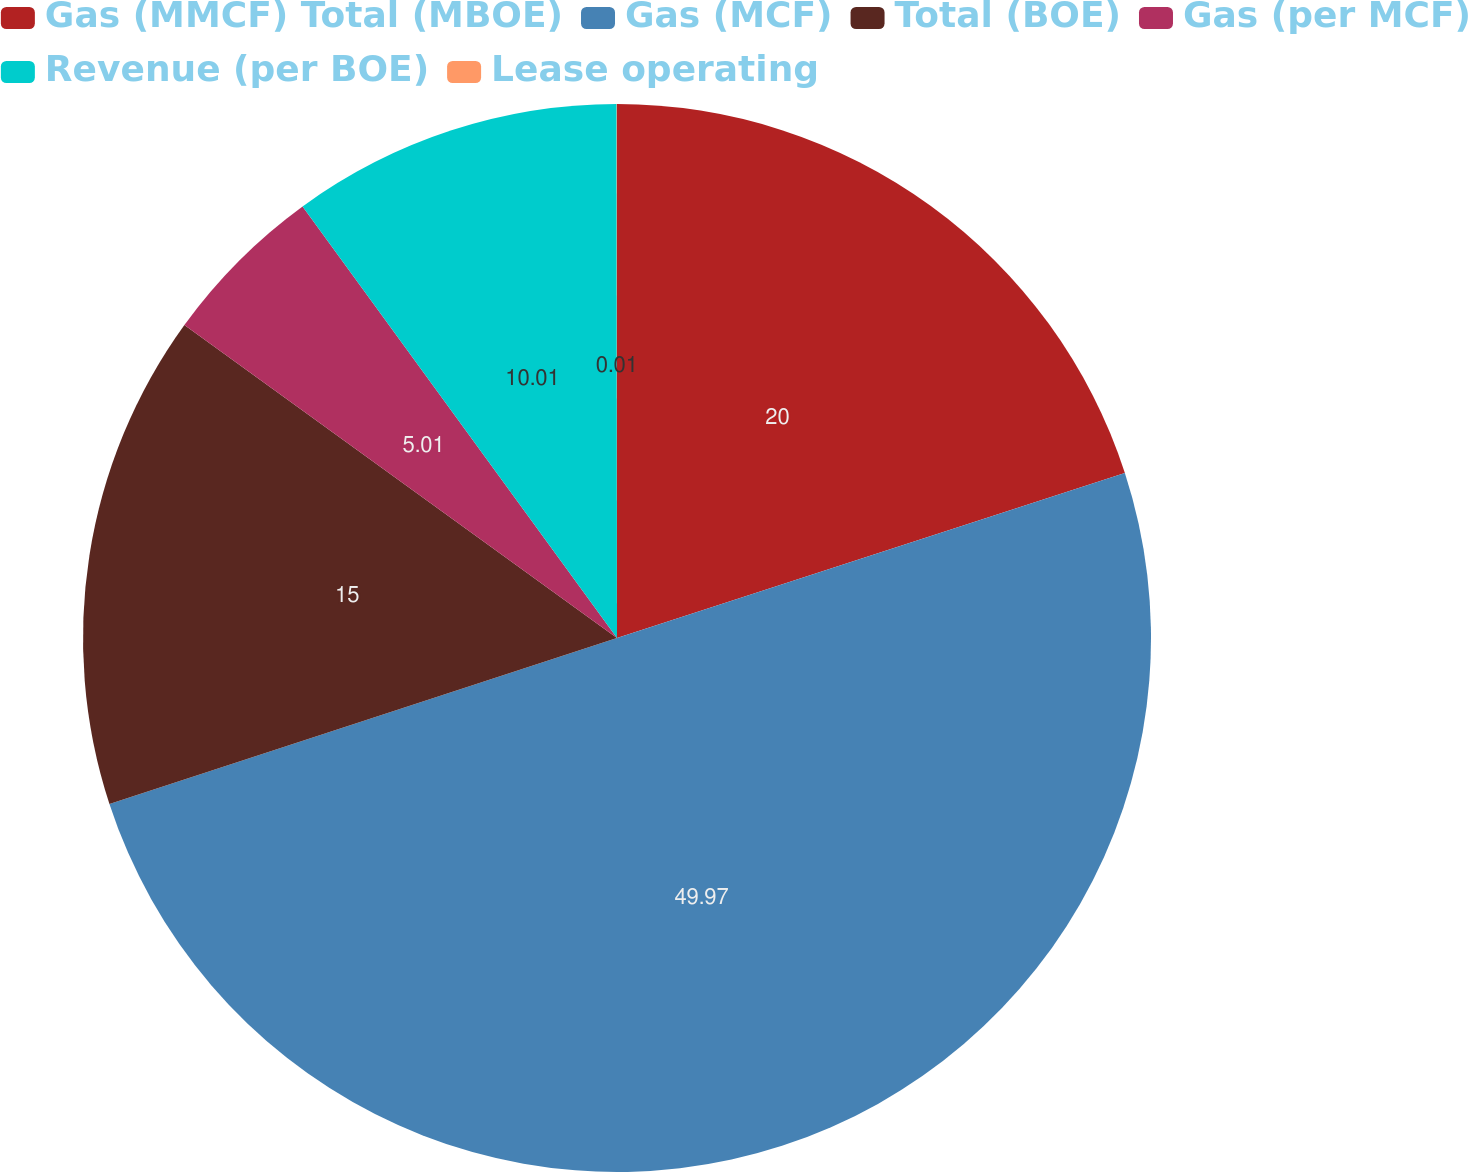Convert chart to OTSL. <chart><loc_0><loc_0><loc_500><loc_500><pie_chart><fcel>Gas (MMCF) Total (MBOE)<fcel>Gas (MCF)<fcel>Total (BOE)<fcel>Gas (per MCF)<fcel>Revenue (per BOE)<fcel>Lease operating<nl><fcel>20.0%<fcel>49.97%<fcel>15.0%<fcel>5.01%<fcel>10.01%<fcel>0.01%<nl></chart> 